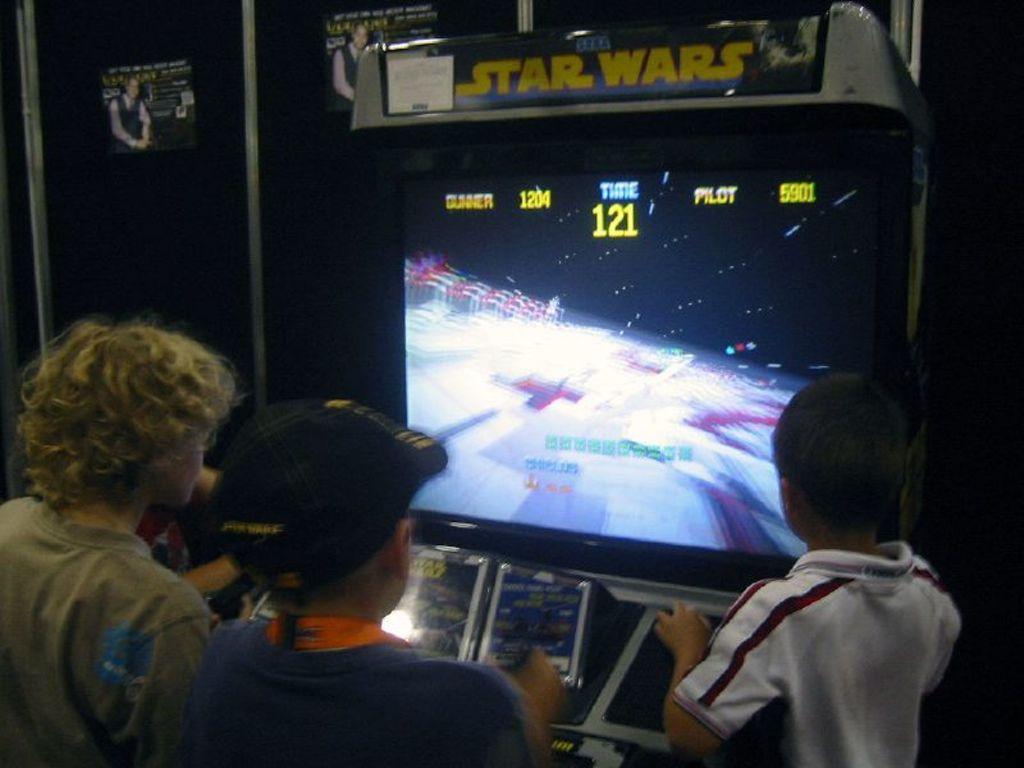How would you summarize this image in a sentence or two? In this image I see the video game screen and I see 3 boys over here and I see words written over here and I see the background which is a bit dark and I see posts over here. 